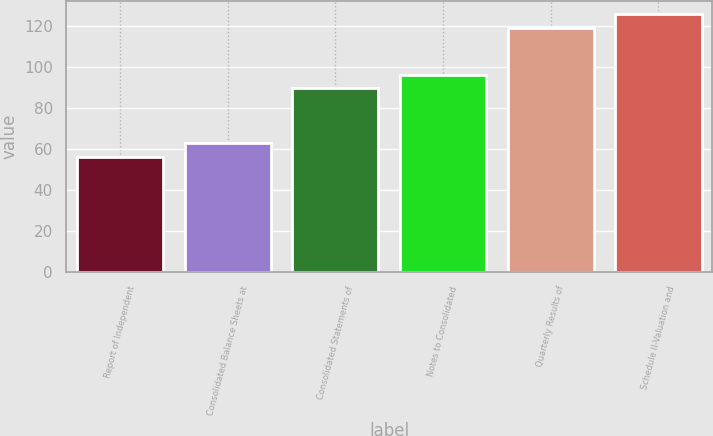Convert chart to OTSL. <chart><loc_0><loc_0><loc_500><loc_500><bar_chart><fcel>Report of Independent<fcel>Consolidated Balance Sheets at<fcel>Consolidated Statements of<fcel>Notes to Consolidated<fcel>Quarterly Results of<fcel>Schedule II-Valuation and<nl><fcel>56<fcel>62.7<fcel>89.5<fcel>96.2<fcel>119<fcel>125.7<nl></chart> 